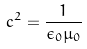<formula> <loc_0><loc_0><loc_500><loc_500>c ^ { 2 } = \frac { 1 } { \epsilon _ { 0 } \mu _ { 0 } }</formula> 